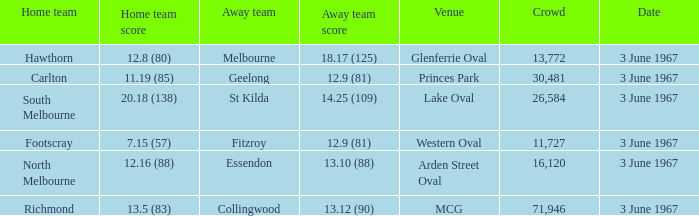What was Hawthorn's score as the home team? 12.8 (80). Could you parse the entire table as a dict? {'header': ['Home team', 'Home team score', 'Away team', 'Away team score', 'Venue', 'Crowd', 'Date'], 'rows': [['Hawthorn', '12.8 (80)', 'Melbourne', '18.17 (125)', 'Glenferrie Oval', '13,772', '3 June 1967'], ['Carlton', '11.19 (85)', 'Geelong', '12.9 (81)', 'Princes Park', '30,481', '3 June 1967'], ['South Melbourne', '20.18 (138)', 'St Kilda', '14.25 (109)', 'Lake Oval', '26,584', '3 June 1967'], ['Footscray', '7.15 (57)', 'Fitzroy', '12.9 (81)', 'Western Oval', '11,727', '3 June 1967'], ['North Melbourne', '12.16 (88)', 'Essendon', '13.10 (88)', 'Arden Street Oval', '16,120', '3 June 1967'], ['Richmond', '13.5 (83)', 'Collingwood', '13.12 (90)', 'MCG', '71,946', '3 June 1967']]} 